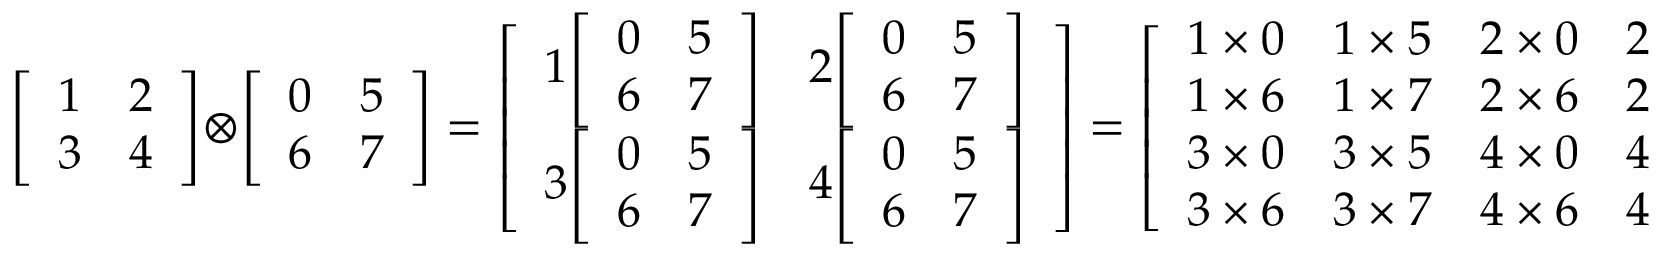Convert formula to latex. <formula><loc_0><loc_0><loc_500><loc_500>{ \left [ \begin{array} { l l } { 1 } & { 2 } \\ { 3 } & { 4 } \end{array} \right ] } \otimes { \left [ \begin{array} { l l } { 0 } & { 5 } \\ { 6 } & { 7 } \end{array} \right ] } = { \left [ \begin{array} { l l } { 1 { \left [ \begin{array} { l l } { 0 } & { 5 } \\ { 6 } & { 7 } \end{array} \right ] } } & { 2 { \left [ \begin{array} { l l } { 0 } & { 5 } \\ { 6 } & { 7 } \end{array} \right ] } } \\ { 3 { \left [ \begin{array} { l l } { 0 } & { 5 } \\ { 6 } & { 7 } \end{array} \right ] } } & { 4 { \left [ \begin{array} { l l } { 0 } & { 5 } \\ { 6 } & { 7 } \end{array} \right ] } } \end{array} \right ] } = { \left [ \begin{array} { l l l l } { 1 \times 0 } & { 1 \times 5 } & { 2 \times 0 } & { 2 \times 5 } \\ { 1 \times 6 } & { 1 \times 7 } & { 2 \times 6 } & { 2 \times 7 } \\ { 3 \times 0 } & { 3 \times 5 } & { 4 \times 0 } & { 4 \times 5 } \\ { 3 \times 6 } & { 3 \times 7 } & { 4 \times 6 } & { 4 \times 7 } \end{array} \right ] } = { \left [ \begin{array} { l l l l } { 0 } & { 5 } & { 0 } & { 1 0 } \\ { 6 } & { 7 } & { 1 2 } & { 1 4 } \\ { 0 } & { 1 5 } & { 0 } & { 2 0 } \\ { 1 8 } & { 2 1 } & { 2 4 } & { 2 8 } \end{array} \right ] } .</formula> 